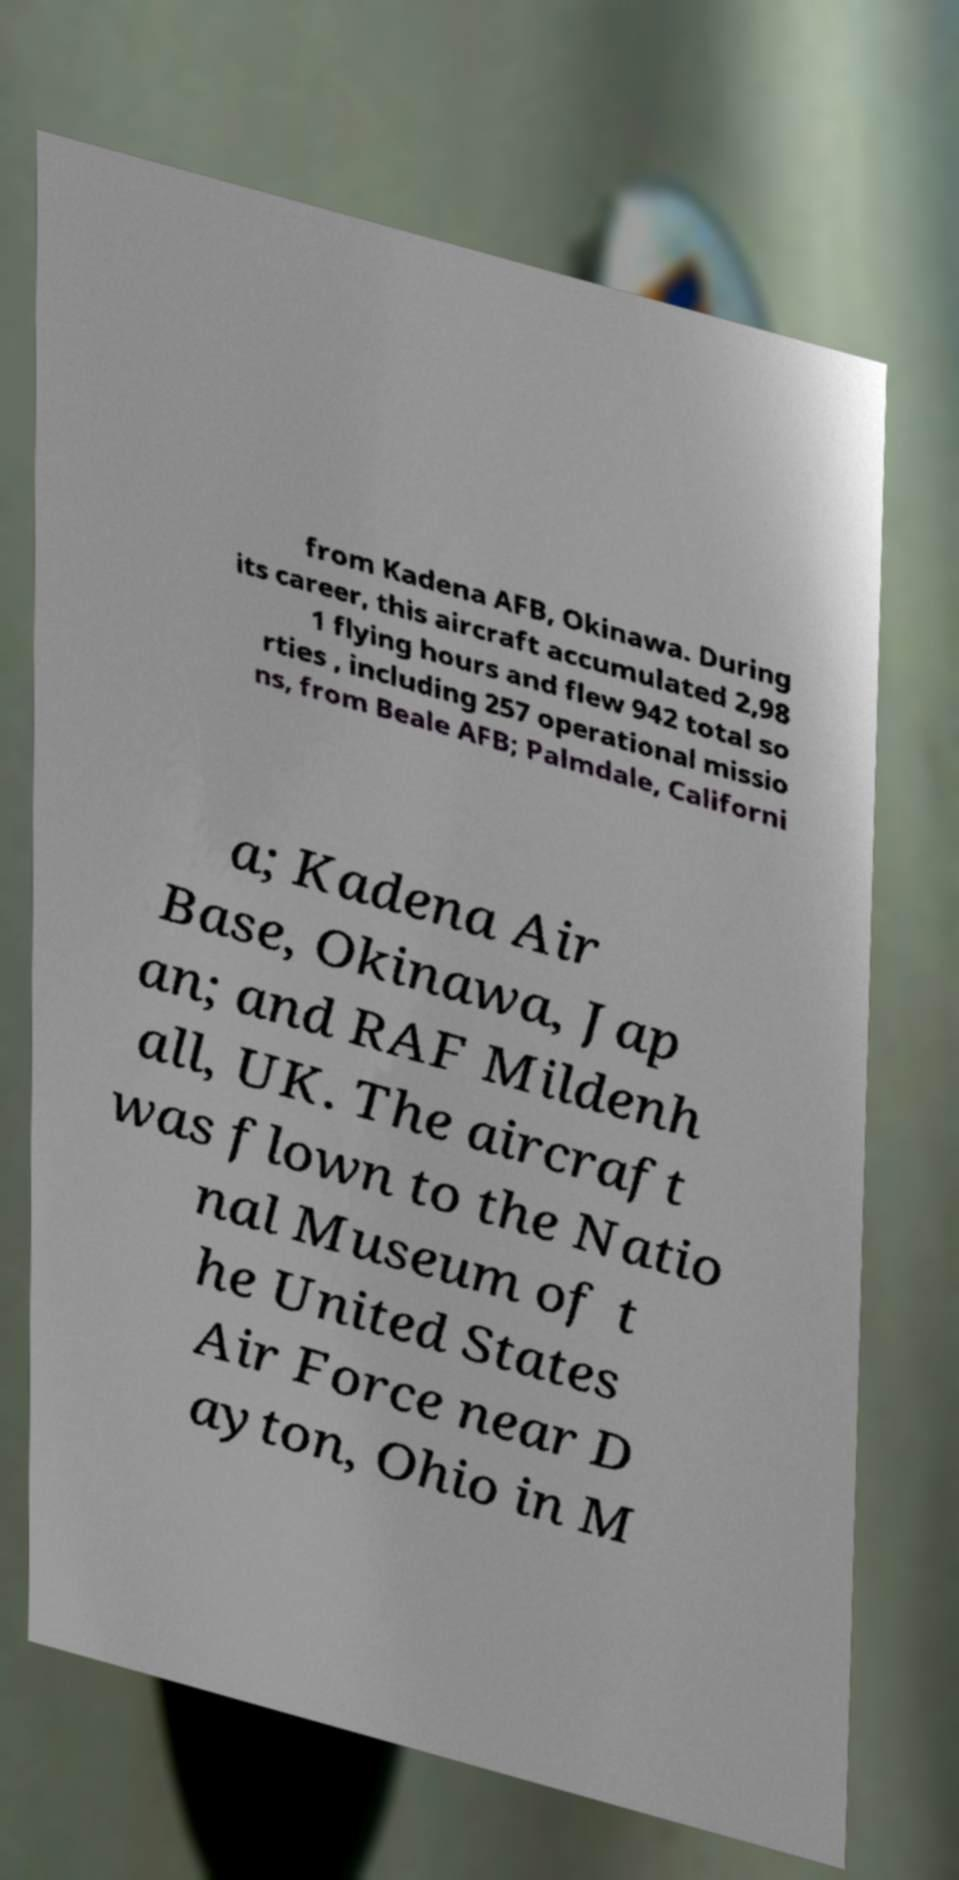I need the written content from this picture converted into text. Can you do that? from Kadena AFB, Okinawa. During its career, this aircraft accumulated 2,98 1 flying hours and flew 942 total so rties , including 257 operational missio ns, from Beale AFB; Palmdale, Californi a; Kadena Air Base, Okinawa, Jap an; and RAF Mildenh all, UK. The aircraft was flown to the Natio nal Museum of t he United States Air Force near D ayton, Ohio in M 